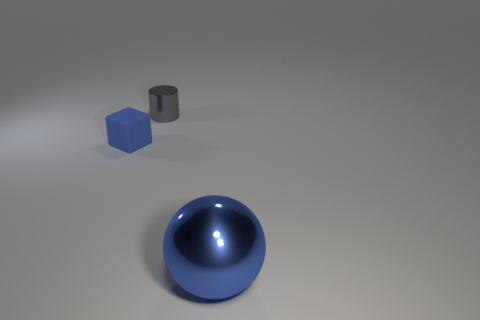Add 3 metallic spheres. How many objects exist? 6 Subtract 1 gray cylinders. How many objects are left? 2 Subtract all balls. How many objects are left? 2 Subtract all cyan spheres. Subtract all yellow cylinders. How many spheres are left? 1 Subtract all purple blocks. How many gray spheres are left? 0 Subtract all red rubber things. Subtract all large metal spheres. How many objects are left? 2 Add 1 gray objects. How many gray objects are left? 2 Add 3 gray spheres. How many gray spheres exist? 3 